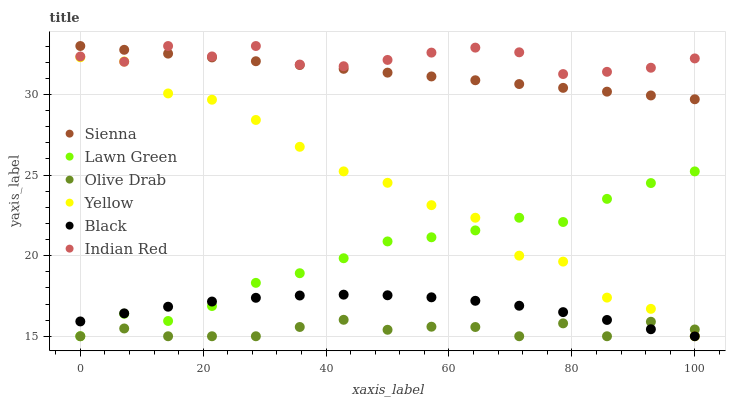Does Olive Drab have the minimum area under the curve?
Answer yes or no. Yes. Does Indian Red have the maximum area under the curve?
Answer yes or no. Yes. Does Yellow have the minimum area under the curve?
Answer yes or no. No. Does Yellow have the maximum area under the curve?
Answer yes or no. No. Is Sienna the smoothest?
Answer yes or no. Yes. Is Yellow the roughest?
Answer yes or no. Yes. Is Yellow the smoothest?
Answer yes or no. No. Is Sienna the roughest?
Answer yes or no. No. Does Lawn Green have the lowest value?
Answer yes or no. Yes. Does Sienna have the lowest value?
Answer yes or no. No. Does Indian Red have the highest value?
Answer yes or no. Yes. Does Yellow have the highest value?
Answer yes or no. No. Is Olive Drab less than Indian Red?
Answer yes or no. Yes. Is Sienna greater than Black?
Answer yes or no. Yes. Does Lawn Green intersect Olive Drab?
Answer yes or no. Yes. Is Lawn Green less than Olive Drab?
Answer yes or no. No. Is Lawn Green greater than Olive Drab?
Answer yes or no. No. Does Olive Drab intersect Indian Red?
Answer yes or no. No. 